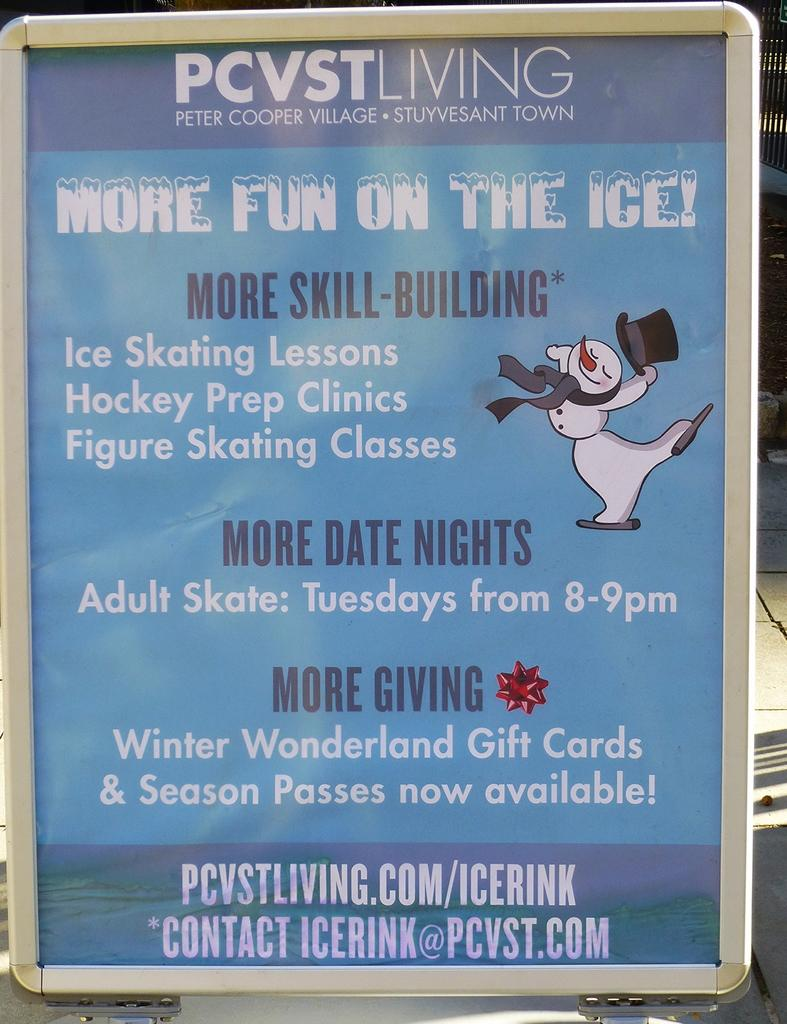<image>
Create a compact narrative representing the image presented. An advertisement for and ice rink is in a silver frame. 